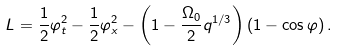<formula> <loc_0><loc_0><loc_500><loc_500>L = \frac { 1 } { 2 } \varphi _ { t } ^ { 2 } - \frac { 1 } { 2 } \varphi _ { x } ^ { 2 } - \left ( 1 - \frac { \Omega _ { 0 } } { 2 } q ^ { 1 / 3 } \right ) \left ( 1 - \cos \varphi \right ) .</formula> 